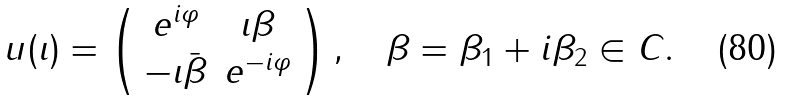<formula> <loc_0><loc_0><loc_500><loc_500>u ( \iota ) = \left ( \begin{array} { c c } e ^ { i \varphi } & \iota \beta \\ - \iota \bar { \beta } & e ^ { - i \varphi } \end{array} \right ) , \quad \beta = \beta _ { 1 } + i \beta _ { 2 } \in { C } .</formula> 